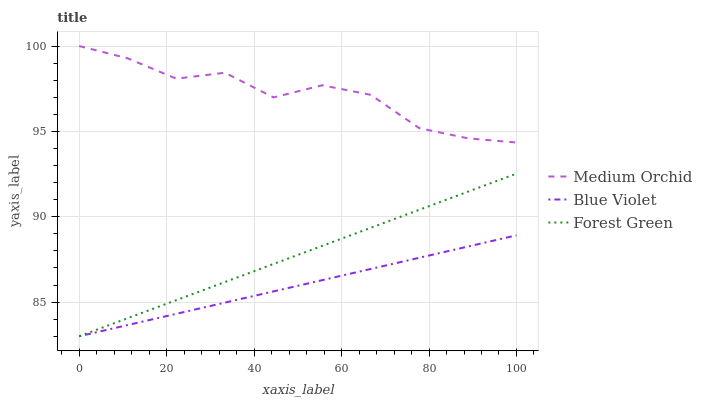Does Blue Violet have the minimum area under the curve?
Answer yes or no. Yes. Does Medium Orchid have the maximum area under the curve?
Answer yes or no. Yes. Does Medium Orchid have the minimum area under the curve?
Answer yes or no. No. Does Blue Violet have the maximum area under the curve?
Answer yes or no. No. Is Forest Green the smoothest?
Answer yes or no. Yes. Is Medium Orchid the roughest?
Answer yes or no. Yes. Is Blue Violet the smoothest?
Answer yes or no. No. Is Blue Violet the roughest?
Answer yes or no. No. Does Forest Green have the lowest value?
Answer yes or no. Yes. Does Medium Orchid have the lowest value?
Answer yes or no. No. Does Medium Orchid have the highest value?
Answer yes or no. Yes. Does Blue Violet have the highest value?
Answer yes or no. No. Is Forest Green less than Medium Orchid?
Answer yes or no. Yes. Is Medium Orchid greater than Forest Green?
Answer yes or no. Yes. Does Blue Violet intersect Forest Green?
Answer yes or no. Yes. Is Blue Violet less than Forest Green?
Answer yes or no. No. Is Blue Violet greater than Forest Green?
Answer yes or no. No. Does Forest Green intersect Medium Orchid?
Answer yes or no. No. 